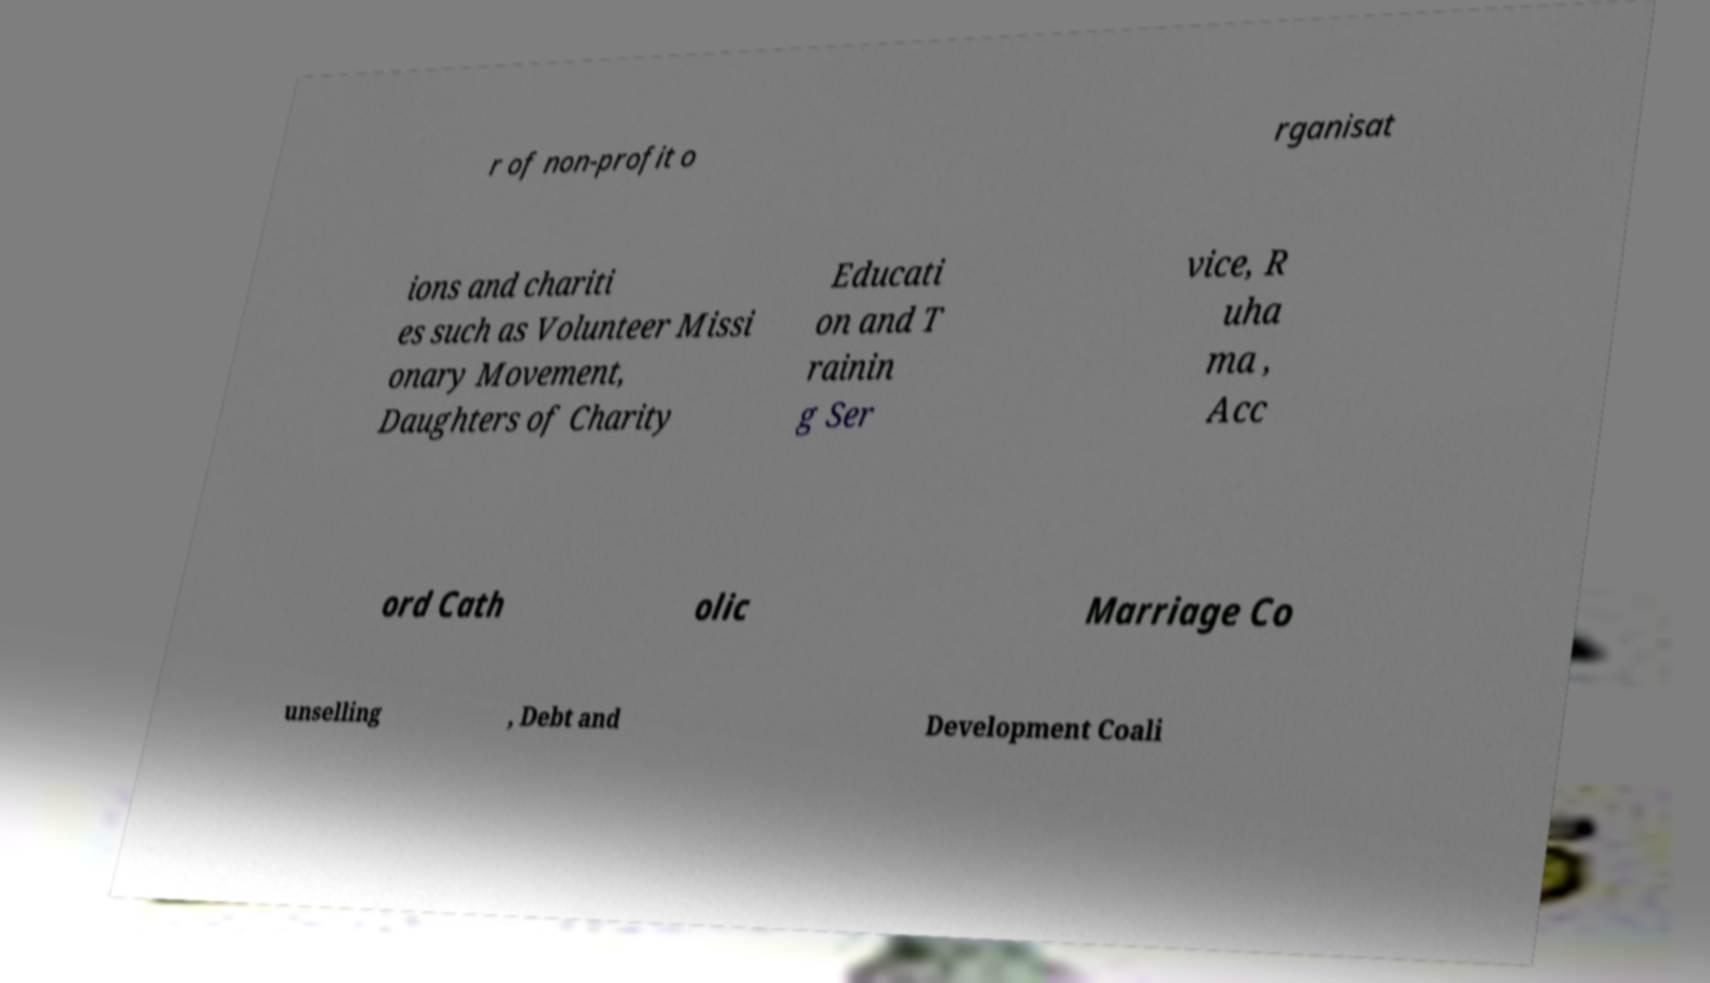For documentation purposes, I need the text within this image transcribed. Could you provide that? r of non-profit o rganisat ions and chariti es such as Volunteer Missi onary Movement, Daughters of Charity Educati on and T rainin g Ser vice, R uha ma , Acc ord Cath olic Marriage Co unselling , Debt and Development Coali 